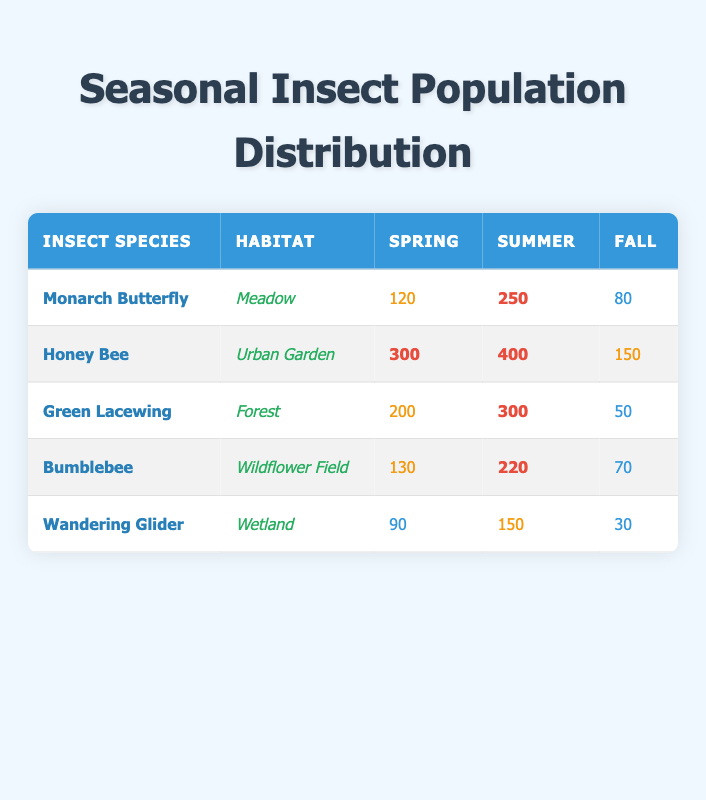What is the population count of the Honey Bee in Summer? The table indicates that the Honey Bee's population in the Summer row is 400.
Answer: 400 Which insect species has the highest population in Spring? In Spring, the populations listed are 120 for Monarch Butterfly, 300 for Honey Bee, 200 for Green Lacewing, 130 for Bumblebee, and 90 for Wandering Glider. The Honey Bee has the highest population at 300.
Answer: Honey Bee What is the difference in population count between the Monarch Butterfly in Summer and Fall? The population count for the Monarch Butterfly in Summer is 250 and in Fall is 80. The difference is 250 - 80 = 170.
Answer: 170 Is the population of the Wandering Glider higher in Summer than in Spring? The Wandering Glider has a population of 150 in Summer and 90 in Spring. Since 150 is greater than 90, the statement is true.
Answer: Yes What is the total population of the Green Lacewing across all seasons? The populations of the Green Lacewing are 200 in Spring, 300 in Summer, and 50 in Fall. Summing these gives 200 + 300 + 50 = 550.
Answer: 550 Which habitat has the highest population of insects in any single season and what is that population? Looking at the maximum values in the table, the highest population is from the Honey Bee in Summer with 400. Checking other species, the maximums do not exceed this number.
Answer: Urban Garden, 400 What is the average population of the Bumblebee across the three seasons? The Bumblebee population counts are 130 in Spring, 220 in Summer, and 70 in Fall. To find the average, sum these: 130 + 220 + 70 = 420, and then divide by 3, yielding 420/3 = 140.
Answer: 140 Which insect has the least population in Fall? In Fall, the populations are 80 for Monarch Butterfly, 150 for Honey Bee, 50 for Green Lacewing, 70 for Bumblebee, and 30 for Wandering Glider. The least is 30 for Wandering Glider.
Answer: Wandering Glider What percentage of the Honey Bee population in Spring is greater than the Monarch Butterfly's population in Spring? The Honey Bee has a population of 300 in Spring, and the Monarch Butterfly has 120. The difference is 300 - 120 = 180. To find the percentage, (180 / 120) * 100 = 150%.
Answer: 150% 